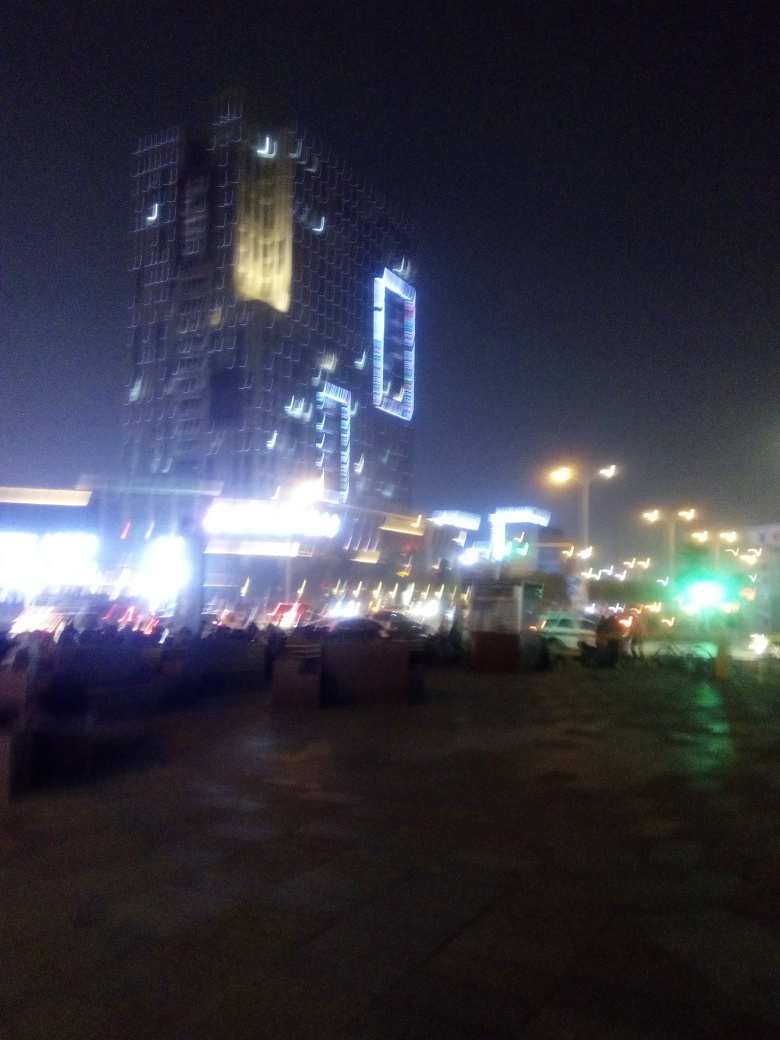How is the lighting in the image? The image showcases an evening or night scene characterized by artificial lights, which are illuminated variedly across different areas. In particular, several buildings are lit with bright lights, indicating either their significance or activity within. There's a notable contrast between the well-lit areas and the surrounding darkness, emphasizing the urban nighttime atmosphere. However, the image's overall quality is low, which causes a blur effect, and it's difficult to determine the lighting conditions accurately. 